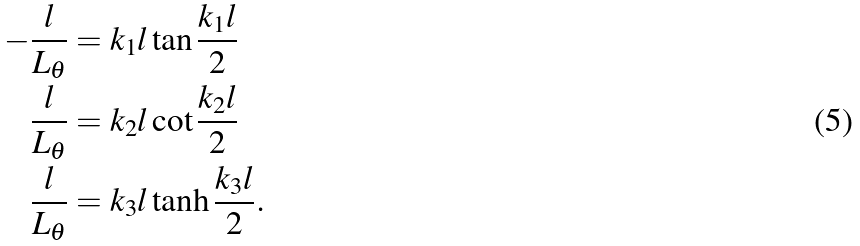<formula> <loc_0><loc_0><loc_500><loc_500>- \frac { l } { L _ { \theta } } & = k _ { 1 } l \tan \frac { k _ { 1 } l } { 2 } \\ \frac { l } { L _ { \theta } } & = k _ { 2 } l \cot \frac { k _ { 2 } l } { 2 } \\ \frac { l } { L _ { \theta } } & = k _ { 3 } l \tanh \frac { k _ { 3 } l } { 2 } .</formula> 